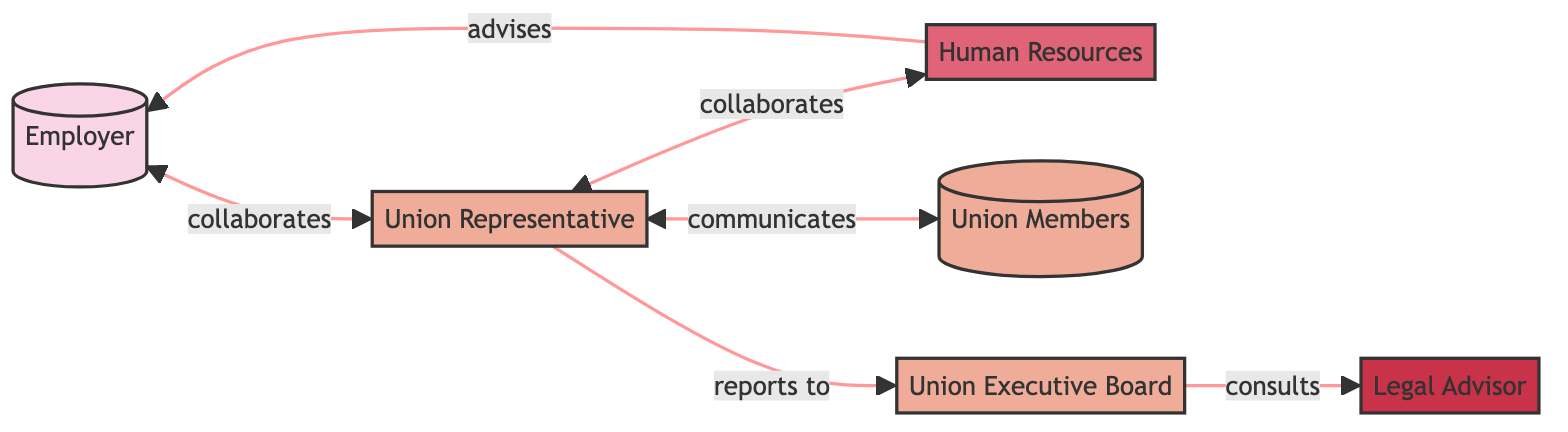What is the role of the Union Representative? The Union Representative serves as the main point of contact between the union and its members, responsible for communicating policies, grievances, and updates.
Answer: Main point of contact between union and members How many nodes are present in this network diagram? By counting the listed entities, I find there are six distinct nodes representing various roles: Employer, Union Representative, Human Resources, Union Members, Union Executive Board, and Legal Advisor.
Answer: 6 Who does the Union Executive Board consult with? According to the diagram, the Union Executive Board connects with the Legal Advisor for legal guidance on union matters, indicating a consulting relationship.
Answer: Legal Advisor What type of interaction exists between the Employer and Union Representative? The diagram shows a bidirectional connection labeled as "collaborates with," indicating they engage in mutual support and cooperation in addressing union initiatives.
Answer: collaborates with How many edges are there in total within this network? By examining the relationships outlined, I see there are five connections (edges) illustrating different interactions between the nodes, leading to a total of five edges in the diagram.
Answer: 5 How do Union Members receive information? The diagram specifies that the Union Representative communicates important information to the Union Members, signifying a one-directional channel for information flow.
Answer: from the Union Representative Which department advises the Employer on labor practices? The Human Resources Department, as indicated in the diagram, plays the role of providing advice to the Employer regarding fair labor practices and supports communication with the Union Representative.
Answer: Human Resources Department What is the relationship between Union Representative and Union Executive Board? In the diagram, the Union Representative reports to the Union Executive Board, indicating a hierarchical relationship where feedback and activities are shared.
Answer: reports to What is the nature of collaboration between Union Representative and Human Resources? The diagram indicates that the Union Representative collaborates with the Human Resources Department to ensure that labor practices align with legal standards and fairness.
Answer: collaborates with 